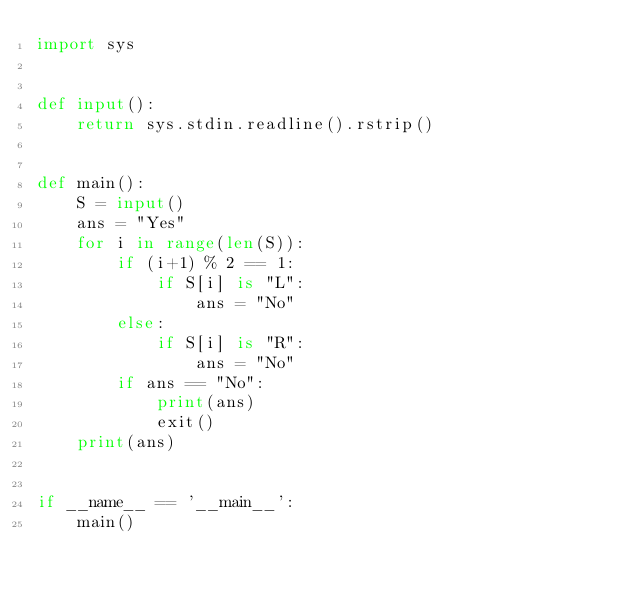Convert code to text. <code><loc_0><loc_0><loc_500><loc_500><_Python_>import sys


def input():
    return sys.stdin.readline().rstrip()


def main():
    S = input()
    ans = "Yes"
    for i in range(len(S)):
        if (i+1) % 2 == 1:
            if S[i] is "L":
                ans = "No"
        else:
            if S[i] is "R":
                ans = "No"
        if ans == "No":
            print(ans)
            exit()
    print(ans)


if __name__ == '__main__':
    main()
</code> 